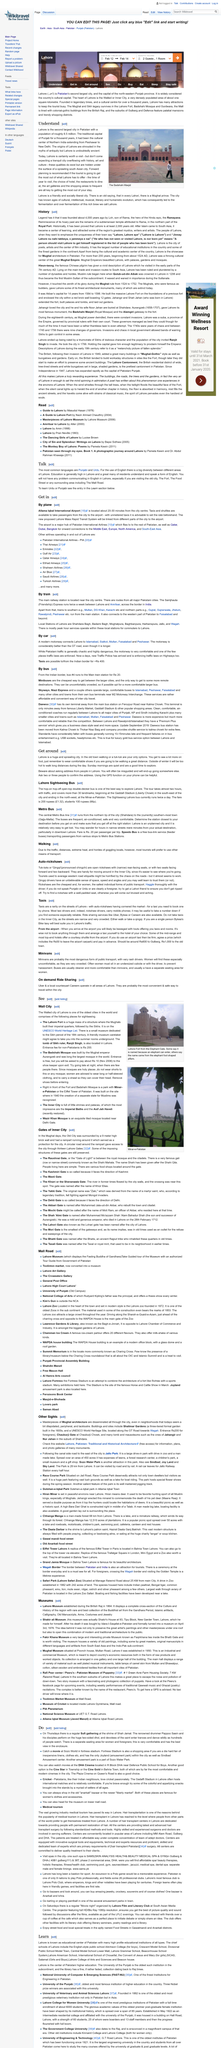Give some essential details in this illustration. Lahore is a city that is massive in size and complexity, commonly referred to as a huge and sprawling city. It is my intention to explore Lahore by using both a sightseeing bus and walking as my modes of transportation. The main station offers train services to both southern and northern regions, providing convenient transportation options for passengers. The Crescent Model School is one of the leading schools in Lahore, as evidenced by its status as a prominent institution in the city. The article is discussing a city in Pakistan that is currently unknown. 